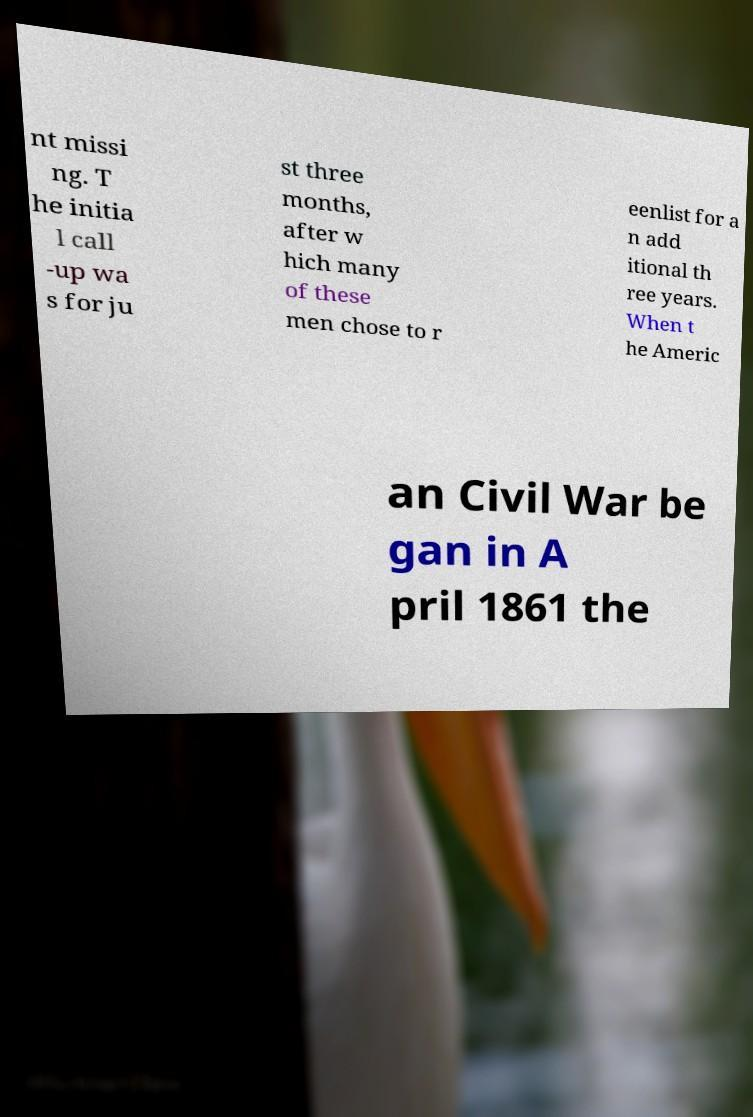Can you accurately transcribe the text from the provided image for me? nt missi ng. T he initia l call -up wa s for ju st three months, after w hich many of these men chose to r eenlist for a n add itional th ree years. When t he Americ an Civil War be gan in A pril 1861 the 